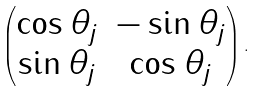<formula> <loc_0><loc_0><loc_500><loc_500>\left ( \begin{matrix} \cos \theta _ { j } & - \sin \theta _ { j } \\ \sin \theta _ { j } & \cos \theta _ { j } \end{matrix} \right ) .</formula> 